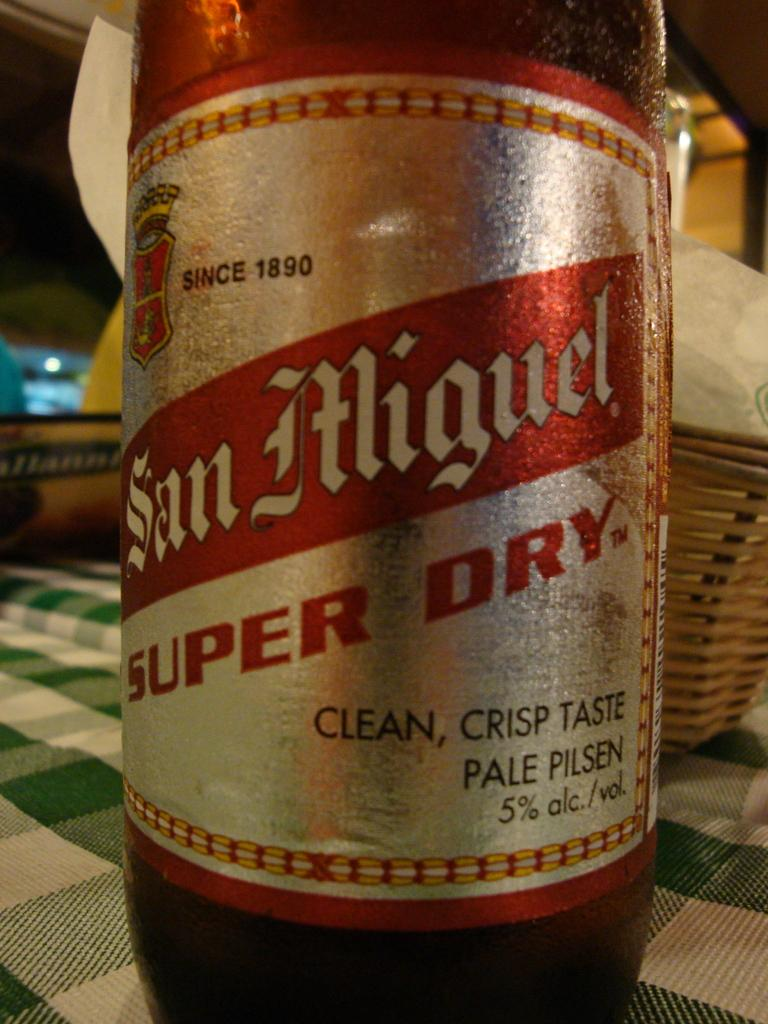<image>
Create a compact narrative representing the image presented. A bottle of beer labeled San Miguel Super Dry is on a green checked table cloth. 